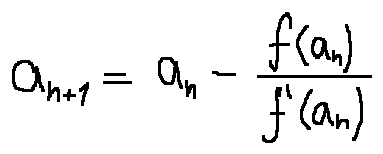<formula> <loc_0><loc_0><loc_500><loc_500>a _ { n + 1 } = a _ { n } - \frac { f ( a _ { n } ) } { f ^ { \prime } ( a _ { n } ) }</formula> 